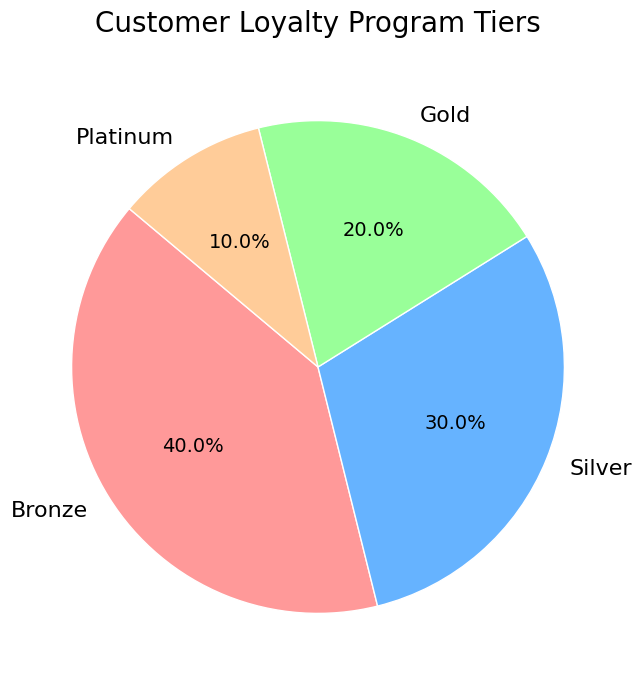What percent of customers are in the Bronze tier? The pie chart shows the distribution of customer loyalty program tiers, and the Bronze tier occupies 40% of the chart.
Answer: 40% Which tier has the smallest percentage of customers? The pie chart includes four tiers with their respective percentages: Bronze (40%), Silver (30%), Gold (20%), and Platinum (10%). The tier with the smallest percentage is Platinum at 10%.
Answer: Platinum How much larger is the Silver tier compared to the Platinum tier in terms of percentage? The Silver tier is 30%, and the Platinum tier is 10%. The difference in their percentages is 30% - 10% = 20%.
Answer: 20% If you combine the Gold and Platinum tiers, what percentage of customers does this represent? The Gold tier represents 20% and the Platinum tier represents 10%. Adding these together gives 20% + 10% = 30%.
Answer: 30% Which tier takes up the largest segment of the pie chart? Observing the pie chart, the largest segment is the one labeled "Bronze" with a percentage of 40%.
Answer: Bronze Are the combined percentages of Silver and Gold tiers equal to the percentage of the Bronze tier? The Silver tier is 30% and the Gold tier is 20%. The combined percentage is 30% + 20% = 50%. The Bronze tier is 40%, so they are not equal.
Answer: No What is the difference in percentage between the Gold and Silver tiers? The Gold tier is 20%, and the Silver tier is 30%. The difference is 30% - 20% = 10%.
Answer: 10% What visual attribute helps in identifying the Silver tier in the chart? The Silver tier segment is colored blue, which visually distinguishes it from the other tiers.
Answer: Blue What percentage more customers are in the Bronze tier compared to the Gold tier? The Bronze tier is 40% and the Gold tier is 20%. The difference is 40% - 20% = 20%. Therefore, 20% more customers are in the Bronze tier compared to the Gold tier.
Answer: 20% What is the sum of the percentages of the Silver and Platinum tiers? The Silver tier is 30% and the Platinum tier is 10%. Adding these together gives 30% + 10% = 40%.
Answer: 40% 